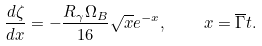<formula> <loc_0><loc_0><loc_500><loc_500>\frac { d \zeta } { d x } = - \frac { R _ { \gamma } \Omega _ { B } } { 1 6 } \sqrt { x } e ^ { - x } , \quad x = \overline { \Gamma } t .</formula> 